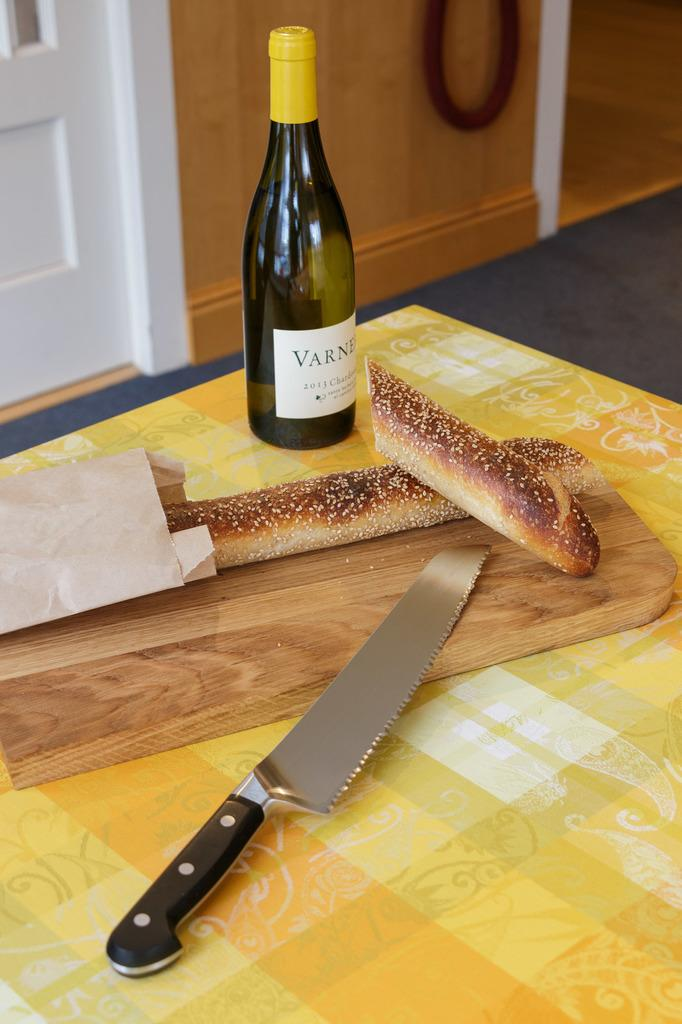What is the main object in the center of the image? There is a table in the center of the image. What items can be seen on the table? There is a knife, bread, a paper, and a bottle on the table. What can be seen in the background of the image? There is a wood wall and a door in the background. How many baby trick trains are visible in the image? There are no baby trick trains present in the image. 